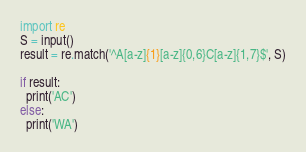Convert code to text. <code><loc_0><loc_0><loc_500><loc_500><_Python_>import re
S = input()
result = re.match('^A[a-z]{1}[a-z]{0,6}C[a-z]{1,7}$', S)

if result:
  print('AC')
else:
  print('WA')</code> 